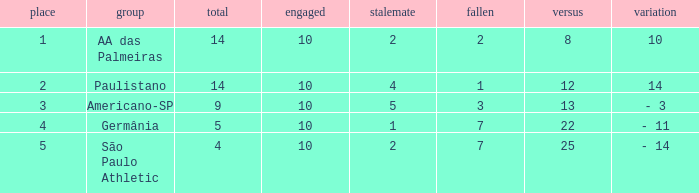With 7 losses, over 4 points, and less than 22 against, what is the highest possible draw count? None. 